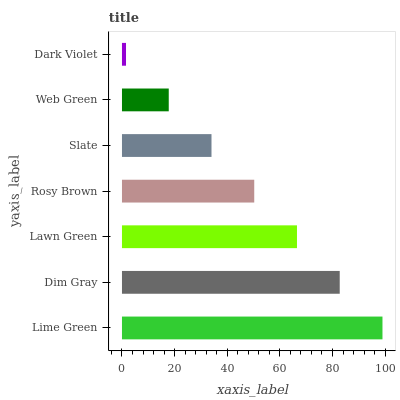Is Dark Violet the minimum?
Answer yes or no. Yes. Is Lime Green the maximum?
Answer yes or no. Yes. Is Dim Gray the minimum?
Answer yes or no. No. Is Dim Gray the maximum?
Answer yes or no. No. Is Lime Green greater than Dim Gray?
Answer yes or no. Yes. Is Dim Gray less than Lime Green?
Answer yes or no. Yes. Is Dim Gray greater than Lime Green?
Answer yes or no. No. Is Lime Green less than Dim Gray?
Answer yes or no. No. Is Rosy Brown the high median?
Answer yes or no. Yes. Is Rosy Brown the low median?
Answer yes or no. Yes. Is Web Green the high median?
Answer yes or no. No. Is Lime Green the low median?
Answer yes or no. No. 